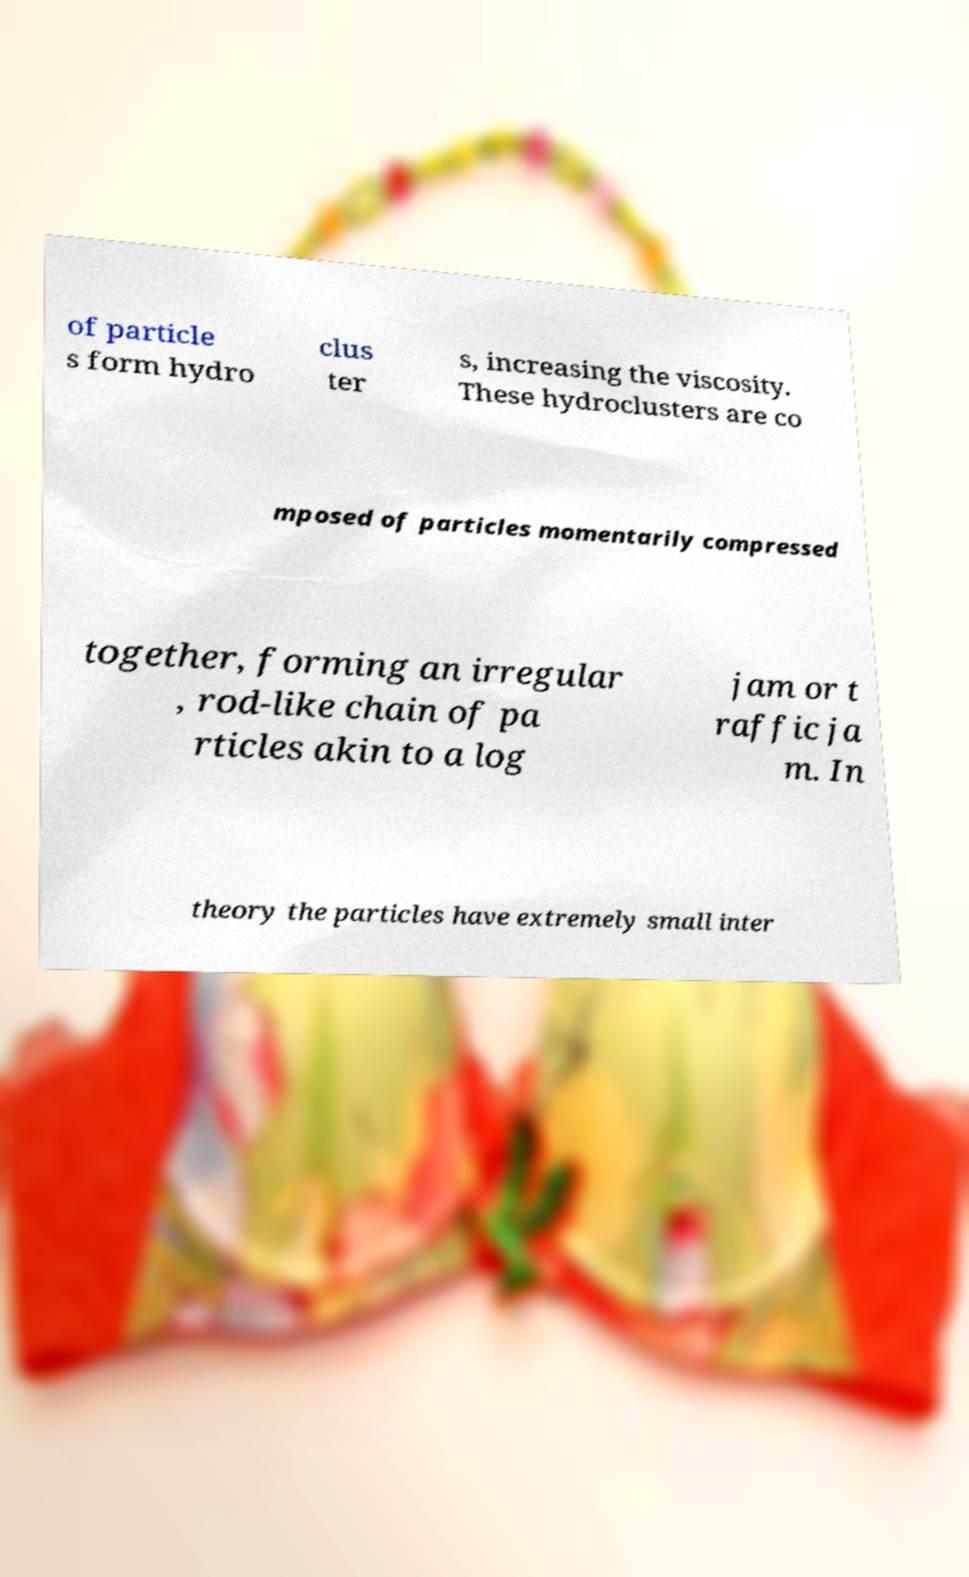What messages or text are displayed in this image? I need them in a readable, typed format. of particle s form hydro clus ter s, increasing the viscosity. These hydroclusters are co mposed of particles momentarily compressed together, forming an irregular , rod-like chain of pa rticles akin to a log jam or t raffic ja m. In theory the particles have extremely small inter 